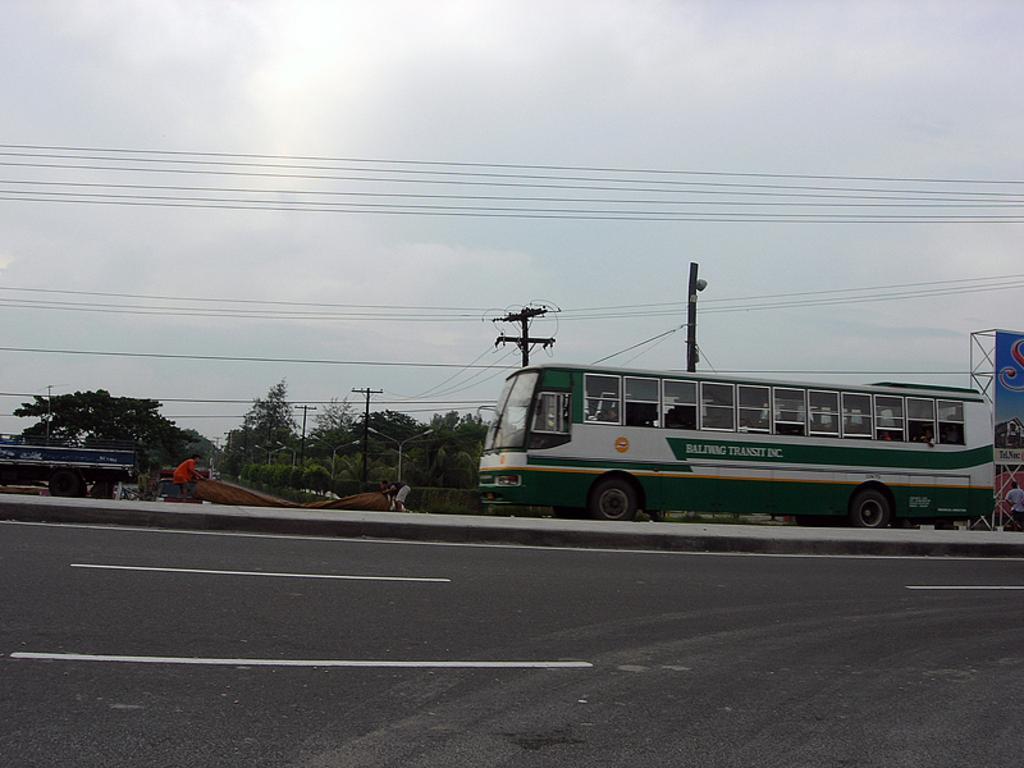Could you give a brief overview of what you see in this image? In the image there is a road and on the road there is a bus and other vehicle. Behind the vehicles there are trees and current poles. 